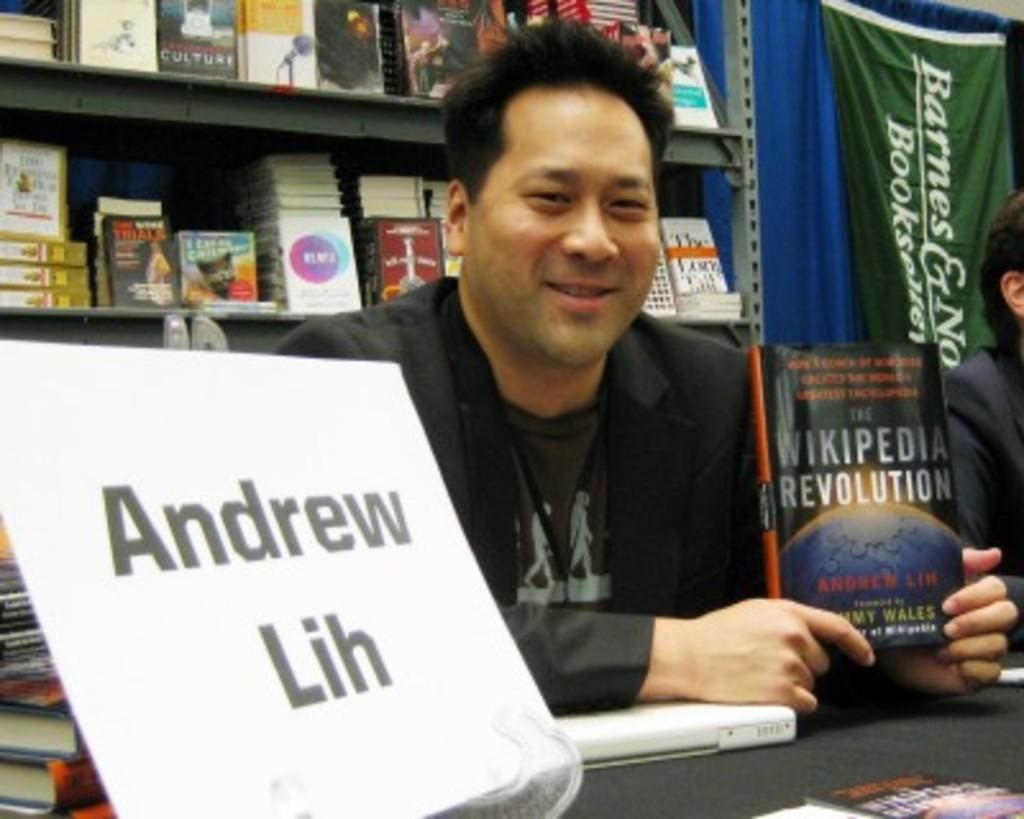Provide a one-sentence caption for the provided image. Andrew Lin holding up his book the Wikipedia Revolution. 